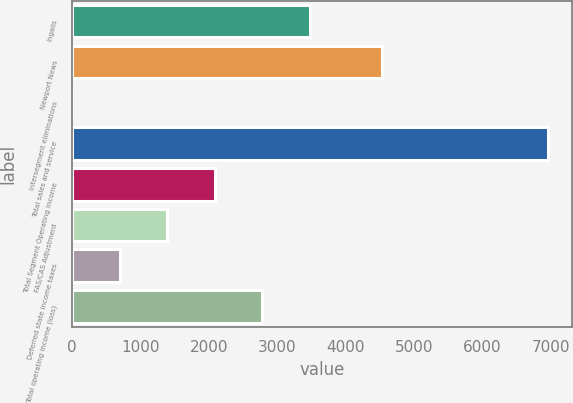Convert chart to OTSL. <chart><loc_0><loc_0><loc_500><loc_500><bar_chart><fcel>Ingalls<fcel>Newport News<fcel>Intersegment eliminations<fcel>Total sales and service<fcel>Total Segment Operating Income<fcel>FAS/CAS Adjustment<fcel>Deferred state income taxes<fcel>Total operating income (loss)<nl><fcel>3479.5<fcel>4536<fcel>2<fcel>6957<fcel>2088.5<fcel>1393<fcel>697.5<fcel>2784<nl></chart> 